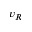Convert formula to latex. <formula><loc_0><loc_0><loc_500><loc_500>v _ { R }</formula> 